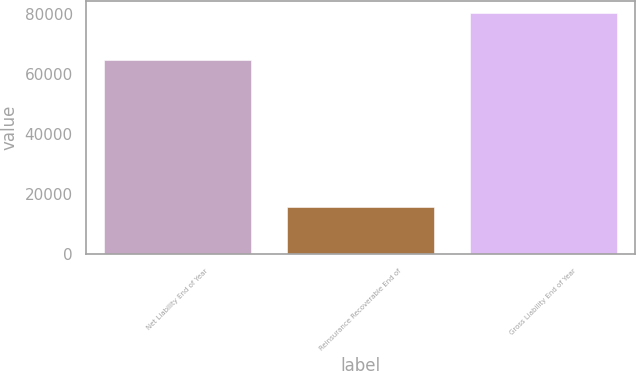Convert chart to OTSL. <chart><loc_0><loc_0><loc_500><loc_500><bar_chart><fcel>Net Liability End of Year<fcel>Reinsurance Recoverable End of<fcel>Gross Liability End of Year<nl><fcel>64689<fcel>15648<fcel>80337<nl></chart> 